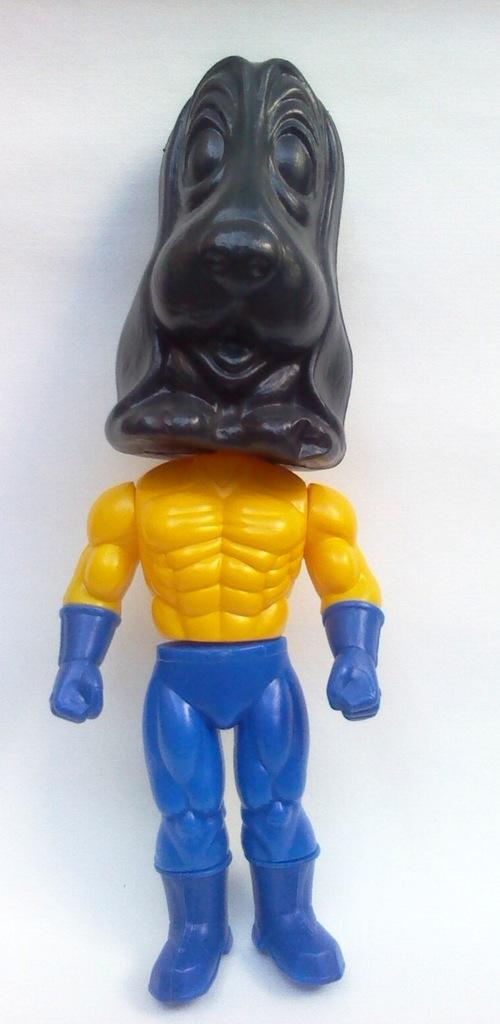What type of toy is present in the image? There is a toy robot in the image. What is the man pointing at on the desk in the image? There is no man, desk, or any pointing action present in the image; it only features a toy robot. 